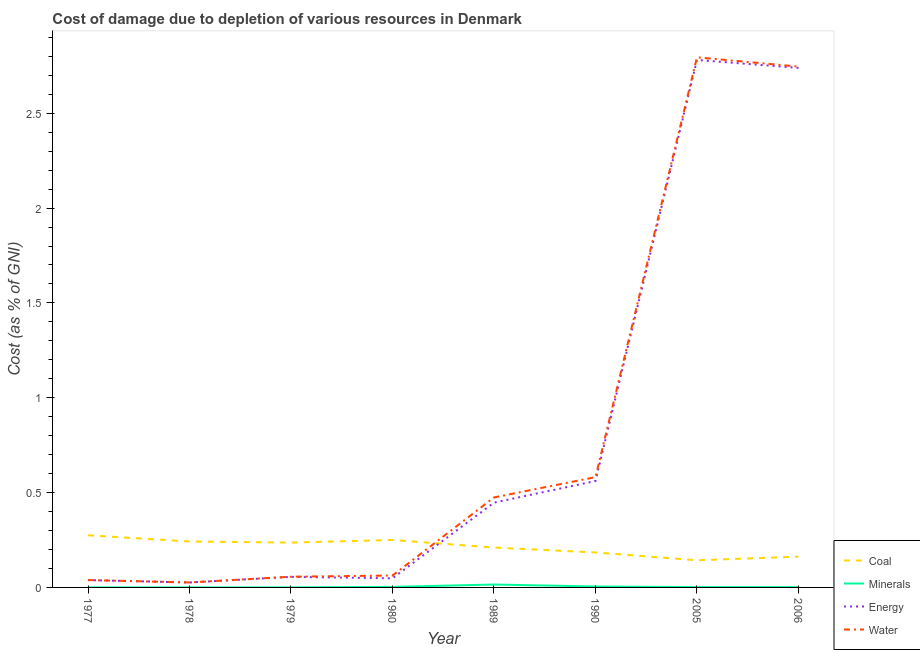How many different coloured lines are there?
Provide a short and direct response. 4. Does the line corresponding to cost of damage due to depletion of water intersect with the line corresponding to cost of damage due to depletion of coal?
Your response must be concise. Yes. What is the cost of damage due to depletion of energy in 2005?
Provide a short and direct response. 2.78. Across all years, what is the maximum cost of damage due to depletion of minerals?
Keep it short and to the point. 0.02. Across all years, what is the minimum cost of damage due to depletion of coal?
Your answer should be very brief. 0.14. In which year was the cost of damage due to depletion of water maximum?
Your response must be concise. 2005. In which year was the cost of damage due to depletion of coal minimum?
Offer a very short reply. 2005. What is the total cost of damage due to depletion of water in the graph?
Make the answer very short. 6.78. What is the difference between the cost of damage due to depletion of coal in 2005 and that in 2006?
Ensure brevity in your answer.  -0.02. What is the difference between the cost of damage due to depletion of coal in 1980 and the cost of damage due to depletion of energy in 1990?
Offer a very short reply. -0.31. What is the average cost of damage due to depletion of water per year?
Keep it short and to the point. 0.85. In the year 1989, what is the difference between the cost of damage due to depletion of energy and cost of damage due to depletion of water?
Your answer should be very brief. -0.03. What is the ratio of the cost of damage due to depletion of coal in 1979 to that in 1990?
Your answer should be very brief. 1.28. What is the difference between the highest and the second highest cost of damage due to depletion of minerals?
Provide a short and direct response. 0.01. What is the difference between the highest and the lowest cost of damage due to depletion of coal?
Give a very brief answer. 0.13. Is it the case that in every year, the sum of the cost of damage due to depletion of coal and cost of damage due to depletion of minerals is greater than the sum of cost of damage due to depletion of energy and cost of damage due to depletion of water?
Offer a terse response. No. Is it the case that in every year, the sum of the cost of damage due to depletion of coal and cost of damage due to depletion of minerals is greater than the cost of damage due to depletion of energy?
Give a very brief answer. No. Does the cost of damage due to depletion of water monotonically increase over the years?
Provide a short and direct response. No. Is the cost of damage due to depletion of energy strictly greater than the cost of damage due to depletion of water over the years?
Provide a succinct answer. No. Is the cost of damage due to depletion of energy strictly less than the cost of damage due to depletion of water over the years?
Give a very brief answer. Yes. How many lines are there?
Your answer should be very brief. 4. How many years are there in the graph?
Offer a terse response. 8. What is the difference between two consecutive major ticks on the Y-axis?
Your answer should be compact. 0.5. Does the graph contain grids?
Offer a terse response. No. Where does the legend appear in the graph?
Give a very brief answer. Bottom right. How are the legend labels stacked?
Provide a succinct answer. Vertical. What is the title of the graph?
Provide a succinct answer. Cost of damage due to depletion of various resources in Denmark . Does "Social equity" appear as one of the legend labels in the graph?
Keep it short and to the point. No. What is the label or title of the X-axis?
Your response must be concise. Year. What is the label or title of the Y-axis?
Provide a short and direct response. Cost (as % of GNI). What is the Cost (as % of GNI) of Coal in 1977?
Your answer should be compact. 0.27. What is the Cost (as % of GNI) of Minerals in 1977?
Provide a short and direct response. 0. What is the Cost (as % of GNI) of Energy in 1977?
Your answer should be very brief. 0.04. What is the Cost (as % of GNI) in Water in 1977?
Your answer should be compact. 0.04. What is the Cost (as % of GNI) in Coal in 1978?
Your answer should be very brief. 0.24. What is the Cost (as % of GNI) of Minerals in 1978?
Your response must be concise. 0. What is the Cost (as % of GNI) of Energy in 1978?
Your answer should be compact. 0.03. What is the Cost (as % of GNI) of Water in 1978?
Make the answer very short. 0.03. What is the Cost (as % of GNI) in Coal in 1979?
Ensure brevity in your answer.  0.24. What is the Cost (as % of GNI) in Minerals in 1979?
Your response must be concise. 0. What is the Cost (as % of GNI) in Energy in 1979?
Offer a very short reply. 0.06. What is the Cost (as % of GNI) in Water in 1979?
Keep it short and to the point. 0.06. What is the Cost (as % of GNI) in Coal in 1980?
Your answer should be compact. 0.25. What is the Cost (as % of GNI) in Minerals in 1980?
Give a very brief answer. 0. What is the Cost (as % of GNI) of Energy in 1980?
Give a very brief answer. 0.05. What is the Cost (as % of GNI) of Water in 1980?
Your answer should be very brief. 0.06. What is the Cost (as % of GNI) in Coal in 1989?
Provide a succinct answer. 0.21. What is the Cost (as % of GNI) in Minerals in 1989?
Ensure brevity in your answer.  0.02. What is the Cost (as % of GNI) in Energy in 1989?
Your answer should be compact. 0.45. What is the Cost (as % of GNI) in Water in 1989?
Your answer should be compact. 0.47. What is the Cost (as % of GNI) of Coal in 1990?
Your response must be concise. 0.18. What is the Cost (as % of GNI) of Minerals in 1990?
Offer a terse response. 0. What is the Cost (as % of GNI) of Energy in 1990?
Keep it short and to the point. 0.56. What is the Cost (as % of GNI) in Water in 1990?
Make the answer very short. 0.58. What is the Cost (as % of GNI) of Coal in 2005?
Keep it short and to the point. 0.14. What is the Cost (as % of GNI) in Minerals in 2005?
Make the answer very short. 0. What is the Cost (as % of GNI) of Energy in 2005?
Your answer should be very brief. 2.78. What is the Cost (as % of GNI) of Water in 2005?
Keep it short and to the point. 2.79. What is the Cost (as % of GNI) in Coal in 2006?
Your answer should be compact. 0.16. What is the Cost (as % of GNI) of Minerals in 2006?
Give a very brief answer. 0. What is the Cost (as % of GNI) in Energy in 2006?
Make the answer very short. 2.74. What is the Cost (as % of GNI) in Water in 2006?
Make the answer very short. 2.75. Across all years, what is the maximum Cost (as % of GNI) of Coal?
Offer a very short reply. 0.27. Across all years, what is the maximum Cost (as % of GNI) in Minerals?
Keep it short and to the point. 0.02. Across all years, what is the maximum Cost (as % of GNI) of Energy?
Offer a terse response. 2.78. Across all years, what is the maximum Cost (as % of GNI) in Water?
Your response must be concise. 2.79. Across all years, what is the minimum Cost (as % of GNI) of Coal?
Keep it short and to the point. 0.14. Across all years, what is the minimum Cost (as % of GNI) in Minerals?
Offer a very short reply. 0. Across all years, what is the minimum Cost (as % of GNI) of Energy?
Offer a very short reply. 0.03. Across all years, what is the minimum Cost (as % of GNI) of Water?
Give a very brief answer. 0.03. What is the total Cost (as % of GNI) of Coal in the graph?
Give a very brief answer. 1.7. What is the total Cost (as % of GNI) in Minerals in the graph?
Your answer should be compact. 0.03. What is the total Cost (as % of GNI) in Energy in the graph?
Keep it short and to the point. 6.7. What is the total Cost (as % of GNI) in Water in the graph?
Give a very brief answer. 6.78. What is the difference between the Cost (as % of GNI) in Coal in 1977 and that in 1978?
Offer a very short reply. 0.03. What is the difference between the Cost (as % of GNI) in Minerals in 1977 and that in 1978?
Your answer should be very brief. 0. What is the difference between the Cost (as % of GNI) of Energy in 1977 and that in 1978?
Give a very brief answer. 0.01. What is the difference between the Cost (as % of GNI) of Water in 1977 and that in 1978?
Keep it short and to the point. 0.01. What is the difference between the Cost (as % of GNI) of Coal in 1977 and that in 1979?
Offer a very short reply. 0.04. What is the difference between the Cost (as % of GNI) in Minerals in 1977 and that in 1979?
Keep it short and to the point. -0. What is the difference between the Cost (as % of GNI) in Energy in 1977 and that in 1979?
Your response must be concise. -0.02. What is the difference between the Cost (as % of GNI) in Water in 1977 and that in 1979?
Give a very brief answer. -0.02. What is the difference between the Cost (as % of GNI) of Coal in 1977 and that in 1980?
Your answer should be very brief. 0.02. What is the difference between the Cost (as % of GNI) of Minerals in 1977 and that in 1980?
Your answer should be very brief. -0. What is the difference between the Cost (as % of GNI) of Energy in 1977 and that in 1980?
Your response must be concise. -0.01. What is the difference between the Cost (as % of GNI) in Water in 1977 and that in 1980?
Provide a succinct answer. -0.02. What is the difference between the Cost (as % of GNI) of Coal in 1977 and that in 1989?
Offer a terse response. 0.06. What is the difference between the Cost (as % of GNI) in Minerals in 1977 and that in 1989?
Your answer should be compact. -0.02. What is the difference between the Cost (as % of GNI) in Energy in 1977 and that in 1989?
Offer a very short reply. -0.41. What is the difference between the Cost (as % of GNI) in Water in 1977 and that in 1989?
Your answer should be very brief. -0.44. What is the difference between the Cost (as % of GNI) in Coal in 1977 and that in 1990?
Offer a very short reply. 0.09. What is the difference between the Cost (as % of GNI) in Minerals in 1977 and that in 1990?
Offer a very short reply. -0. What is the difference between the Cost (as % of GNI) of Energy in 1977 and that in 1990?
Your response must be concise. -0.52. What is the difference between the Cost (as % of GNI) in Water in 1977 and that in 1990?
Keep it short and to the point. -0.54. What is the difference between the Cost (as % of GNI) in Coal in 1977 and that in 2005?
Your answer should be very brief. 0.13. What is the difference between the Cost (as % of GNI) of Minerals in 1977 and that in 2005?
Provide a short and direct response. -0. What is the difference between the Cost (as % of GNI) of Energy in 1977 and that in 2005?
Your answer should be very brief. -2.74. What is the difference between the Cost (as % of GNI) of Water in 1977 and that in 2005?
Provide a succinct answer. -2.76. What is the difference between the Cost (as % of GNI) in Coal in 1977 and that in 2006?
Provide a succinct answer. 0.11. What is the difference between the Cost (as % of GNI) in Minerals in 1977 and that in 2006?
Provide a succinct answer. -0. What is the difference between the Cost (as % of GNI) of Energy in 1977 and that in 2006?
Make the answer very short. -2.7. What is the difference between the Cost (as % of GNI) in Water in 1977 and that in 2006?
Provide a short and direct response. -2.71. What is the difference between the Cost (as % of GNI) in Coal in 1978 and that in 1979?
Provide a short and direct response. 0.01. What is the difference between the Cost (as % of GNI) of Minerals in 1978 and that in 1979?
Your answer should be very brief. -0. What is the difference between the Cost (as % of GNI) in Energy in 1978 and that in 1979?
Your response must be concise. -0.03. What is the difference between the Cost (as % of GNI) in Water in 1978 and that in 1979?
Provide a succinct answer. -0.03. What is the difference between the Cost (as % of GNI) in Coal in 1978 and that in 1980?
Offer a very short reply. -0.01. What is the difference between the Cost (as % of GNI) of Minerals in 1978 and that in 1980?
Offer a very short reply. -0. What is the difference between the Cost (as % of GNI) of Energy in 1978 and that in 1980?
Give a very brief answer. -0.02. What is the difference between the Cost (as % of GNI) of Water in 1978 and that in 1980?
Keep it short and to the point. -0.04. What is the difference between the Cost (as % of GNI) in Coal in 1978 and that in 1989?
Ensure brevity in your answer.  0.03. What is the difference between the Cost (as % of GNI) in Minerals in 1978 and that in 1989?
Provide a succinct answer. -0.02. What is the difference between the Cost (as % of GNI) of Energy in 1978 and that in 1989?
Offer a terse response. -0.42. What is the difference between the Cost (as % of GNI) in Water in 1978 and that in 1989?
Offer a very short reply. -0.45. What is the difference between the Cost (as % of GNI) in Coal in 1978 and that in 1990?
Ensure brevity in your answer.  0.06. What is the difference between the Cost (as % of GNI) of Minerals in 1978 and that in 1990?
Provide a short and direct response. -0. What is the difference between the Cost (as % of GNI) of Energy in 1978 and that in 1990?
Give a very brief answer. -0.54. What is the difference between the Cost (as % of GNI) of Water in 1978 and that in 1990?
Offer a terse response. -0.56. What is the difference between the Cost (as % of GNI) in Coal in 1978 and that in 2005?
Keep it short and to the point. 0.1. What is the difference between the Cost (as % of GNI) of Minerals in 1978 and that in 2005?
Your answer should be compact. -0. What is the difference between the Cost (as % of GNI) in Energy in 1978 and that in 2005?
Provide a short and direct response. -2.75. What is the difference between the Cost (as % of GNI) in Water in 1978 and that in 2005?
Keep it short and to the point. -2.77. What is the difference between the Cost (as % of GNI) in Coal in 1978 and that in 2006?
Offer a very short reply. 0.08. What is the difference between the Cost (as % of GNI) in Minerals in 1978 and that in 2006?
Provide a short and direct response. -0. What is the difference between the Cost (as % of GNI) in Energy in 1978 and that in 2006?
Your answer should be very brief. -2.71. What is the difference between the Cost (as % of GNI) in Water in 1978 and that in 2006?
Keep it short and to the point. -2.72. What is the difference between the Cost (as % of GNI) of Coal in 1979 and that in 1980?
Keep it short and to the point. -0.01. What is the difference between the Cost (as % of GNI) in Minerals in 1979 and that in 1980?
Your response must be concise. -0. What is the difference between the Cost (as % of GNI) of Energy in 1979 and that in 1980?
Provide a short and direct response. 0.01. What is the difference between the Cost (as % of GNI) in Water in 1979 and that in 1980?
Offer a very short reply. -0.01. What is the difference between the Cost (as % of GNI) in Coal in 1979 and that in 1989?
Your answer should be very brief. 0.03. What is the difference between the Cost (as % of GNI) of Minerals in 1979 and that in 1989?
Offer a very short reply. -0.02. What is the difference between the Cost (as % of GNI) in Energy in 1979 and that in 1989?
Offer a terse response. -0.39. What is the difference between the Cost (as % of GNI) in Water in 1979 and that in 1989?
Provide a succinct answer. -0.42. What is the difference between the Cost (as % of GNI) of Coal in 1979 and that in 1990?
Offer a very short reply. 0.05. What is the difference between the Cost (as % of GNI) in Minerals in 1979 and that in 1990?
Offer a terse response. -0. What is the difference between the Cost (as % of GNI) in Energy in 1979 and that in 1990?
Give a very brief answer. -0.51. What is the difference between the Cost (as % of GNI) of Water in 1979 and that in 1990?
Make the answer very short. -0.53. What is the difference between the Cost (as % of GNI) in Coal in 1979 and that in 2005?
Your answer should be compact. 0.09. What is the difference between the Cost (as % of GNI) in Minerals in 1979 and that in 2005?
Make the answer very short. -0. What is the difference between the Cost (as % of GNI) of Energy in 1979 and that in 2005?
Your response must be concise. -2.73. What is the difference between the Cost (as % of GNI) of Water in 1979 and that in 2005?
Provide a short and direct response. -2.74. What is the difference between the Cost (as % of GNI) of Coal in 1979 and that in 2006?
Ensure brevity in your answer.  0.07. What is the difference between the Cost (as % of GNI) in Minerals in 1979 and that in 2006?
Your answer should be compact. -0. What is the difference between the Cost (as % of GNI) of Energy in 1979 and that in 2006?
Offer a very short reply. -2.68. What is the difference between the Cost (as % of GNI) in Water in 1979 and that in 2006?
Offer a terse response. -2.69. What is the difference between the Cost (as % of GNI) of Coal in 1980 and that in 1989?
Make the answer very short. 0.04. What is the difference between the Cost (as % of GNI) of Minerals in 1980 and that in 1989?
Keep it short and to the point. -0.01. What is the difference between the Cost (as % of GNI) in Energy in 1980 and that in 1989?
Ensure brevity in your answer.  -0.4. What is the difference between the Cost (as % of GNI) in Water in 1980 and that in 1989?
Ensure brevity in your answer.  -0.41. What is the difference between the Cost (as % of GNI) of Coal in 1980 and that in 1990?
Offer a very short reply. 0.07. What is the difference between the Cost (as % of GNI) in Minerals in 1980 and that in 1990?
Keep it short and to the point. -0. What is the difference between the Cost (as % of GNI) of Energy in 1980 and that in 1990?
Provide a short and direct response. -0.51. What is the difference between the Cost (as % of GNI) in Water in 1980 and that in 1990?
Keep it short and to the point. -0.52. What is the difference between the Cost (as % of GNI) of Coal in 1980 and that in 2005?
Provide a succinct answer. 0.11. What is the difference between the Cost (as % of GNI) in Minerals in 1980 and that in 2005?
Make the answer very short. 0. What is the difference between the Cost (as % of GNI) of Energy in 1980 and that in 2005?
Your answer should be compact. -2.73. What is the difference between the Cost (as % of GNI) of Water in 1980 and that in 2005?
Make the answer very short. -2.73. What is the difference between the Cost (as % of GNI) of Coal in 1980 and that in 2006?
Your answer should be very brief. 0.09. What is the difference between the Cost (as % of GNI) in Minerals in 1980 and that in 2006?
Your answer should be compact. 0. What is the difference between the Cost (as % of GNI) of Energy in 1980 and that in 2006?
Your answer should be very brief. -2.69. What is the difference between the Cost (as % of GNI) in Water in 1980 and that in 2006?
Provide a short and direct response. -2.68. What is the difference between the Cost (as % of GNI) of Coal in 1989 and that in 1990?
Your answer should be very brief. 0.03. What is the difference between the Cost (as % of GNI) in Minerals in 1989 and that in 1990?
Your answer should be compact. 0.01. What is the difference between the Cost (as % of GNI) in Energy in 1989 and that in 1990?
Offer a very short reply. -0.11. What is the difference between the Cost (as % of GNI) in Water in 1989 and that in 1990?
Ensure brevity in your answer.  -0.11. What is the difference between the Cost (as % of GNI) in Coal in 1989 and that in 2005?
Keep it short and to the point. 0.07. What is the difference between the Cost (as % of GNI) of Minerals in 1989 and that in 2005?
Provide a succinct answer. 0.01. What is the difference between the Cost (as % of GNI) of Energy in 1989 and that in 2005?
Your answer should be compact. -2.33. What is the difference between the Cost (as % of GNI) of Water in 1989 and that in 2005?
Give a very brief answer. -2.32. What is the difference between the Cost (as % of GNI) of Coal in 1989 and that in 2006?
Provide a succinct answer. 0.05. What is the difference between the Cost (as % of GNI) in Minerals in 1989 and that in 2006?
Provide a short and direct response. 0.01. What is the difference between the Cost (as % of GNI) in Energy in 1989 and that in 2006?
Your response must be concise. -2.29. What is the difference between the Cost (as % of GNI) of Water in 1989 and that in 2006?
Your response must be concise. -2.27. What is the difference between the Cost (as % of GNI) in Coal in 1990 and that in 2005?
Your answer should be compact. 0.04. What is the difference between the Cost (as % of GNI) of Minerals in 1990 and that in 2005?
Keep it short and to the point. 0. What is the difference between the Cost (as % of GNI) in Energy in 1990 and that in 2005?
Your answer should be compact. -2.22. What is the difference between the Cost (as % of GNI) of Water in 1990 and that in 2005?
Provide a succinct answer. -2.21. What is the difference between the Cost (as % of GNI) in Coal in 1990 and that in 2006?
Make the answer very short. 0.02. What is the difference between the Cost (as % of GNI) in Minerals in 1990 and that in 2006?
Give a very brief answer. 0. What is the difference between the Cost (as % of GNI) of Energy in 1990 and that in 2006?
Provide a short and direct response. -2.18. What is the difference between the Cost (as % of GNI) of Water in 1990 and that in 2006?
Ensure brevity in your answer.  -2.16. What is the difference between the Cost (as % of GNI) of Coal in 2005 and that in 2006?
Provide a short and direct response. -0.02. What is the difference between the Cost (as % of GNI) in Energy in 2005 and that in 2006?
Provide a succinct answer. 0.04. What is the difference between the Cost (as % of GNI) in Water in 2005 and that in 2006?
Your response must be concise. 0.05. What is the difference between the Cost (as % of GNI) of Coal in 1977 and the Cost (as % of GNI) of Minerals in 1978?
Your answer should be compact. 0.27. What is the difference between the Cost (as % of GNI) in Coal in 1977 and the Cost (as % of GNI) in Energy in 1978?
Give a very brief answer. 0.25. What is the difference between the Cost (as % of GNI) of Coal in 1977 and the Cost (as % of GNI) of Water in 1978?
Give a very brief answer. 0.25. What is the difference between the Cost (as % of GNI) in Minerals in 1977 and the Cost (as % of GNI) in Energy in 1978?
Your answer should be very brief. -0.03. What is the difference between the Cost (as % of GNI) in Minerals in 1977 and the Cost (as % of GNI) in Water in 1978?
Provide a succinct answer. -0.03. What is the difference between the Cost (as % of GNI) of Energy in 1977 and the Cost (as % of GNI) of Water in 1978?
Your answer should be compact. 0.01. What is the difference between the Cost (as % of GNI) in Coal in 1977 and the Cost (as % of GNI) in Minerals in 1979?
Your answer should be very brief. 0.27. What is the difference between the Cost (as % of GNI) of Coal in 1977 and the Cost (as % of GNI) of Energy in 1979?
Provide a short and direct response. 0.22. What is the difference between the Cost (as % of GNI) of Coal in 1977 and the Cost (as % of GNI) of Water in 1979?
Make the answer very short. 0.22. What is the difference between the Cost (as % of GNI) in Minerals in 1977 and the Cost (as % of GNI) in Energy in 1979?
Make the answer very short. -0.06. What is the difference between the Cost (as % of GNI) in Minerals in 1977 and the Cost (as % of GNI) in Water in 1979?
Provide a succinct answer. -0.06. What is the difference between the Cost (as % of GNI) of Energy in 1977 and the Cost (as % of GNI) of Water in 1979?
Offer a very short reply. -0.02. What is the difference between the Cost (as % of GNI) in Coal in 1977 and the Cost (as % of GNI) in Minerals in 1980?
Provide a short and direct response. 0.27. What is the difference between the Cost (as % of GNI) of Coal in 1977 and the Cost (as % of GNI) of Energy in 1980?
Ensure brevity in your answer.  0.23. What is the difference between the Cost (as % of GNI) of Coal in 1977 and the Cost (as % of GNI) of Water in 1980?
Give a very brief answer. 0.21. What is the difference between the Cost (as % of GNI) of Minerals in 1977 and the Cost (as % of GNI) of Energy in 1980?
Ensure brevity in your answer.  -0.05. What is the difference between the Cost (as % of GNI) in Minerals in 1977 and the Cost (as % of GNI) in Water in 1980?
Make the answer very short. -0.06. What is the difference between the Cost (as % of GNI) in Energy in 1977 and the Cost (as % of GNI) in Water in 1980?
Provide a short and direct response. -0.02. What is the difference between the Cost (as % of GNI) in Coal in 1977 and the Cost (as % of GNI) in Minerals in 1989?
Make the answer very short. 0.26. What is the difference between the Cost (as % of GNI) in Coal in 1977 and the Cost (as % of GNI) in Energy in 1989?
Keep it short and to the point. -0.17. What is the difference between the Cost (as % of GNI) of Coal in 1977 and the Cost (as % of GNI) of Water in 1989?
Provide a succinct answer. -0.2. What is the difference between the Cost (as % of GNI) in Minerals in 1977 and the Cost (as % of GNI) in Energy in 1989?
Offer a very short reply. -0.45. What is the difference between the Cost (as % of GNI) of Minerals in 1977 and the Cost (as % of GNI) of Water in 1989?
Keep it short and to the point. -0.47. What is the difference between the Cost (as % of GNI) in Energy in 1977 and the Cost (as % of GNI) in Water in 1989?
Ensure brevity in your answer.  -0.44. What is the difference between the Cost (as % of GNI) of Coal in 1977 and the Cost (as % of GNI) of Minerals in 1990?
Keep it short and to the point. 0.27. What is the difference between the Cost (as % of GNI) in Coal in 1977 and the Cost (as % of GNI) in Energy in 1990?
Provide a succinct answer. -0.29. What is the difference between the Cost (as % of GNI) in Coal in 1977 and the Cost (as % of GNI) in Water in 1990?
Make the answer very short. -0.31. What is the difference between the Cost (as % of GNI) in Minerals in 1977 and the Cost (as % of GNI) in Energy in 1990?
Give a very brief answer. -0.56. What is the difference between the Cost (as % of GNI) in Minerals in 1977 and the Cost (as % of GNI) in Water in 1990?
Make the answer very short. -0.58. What is the difference between the Cost (as % of GNI) in Energy in 1977 and the Cost (as % of GNI) in Water in 1990?
Provide a short and direct response. -0.54. What is the difference between the Cost (as % of GNI) of Coal in 1977 and the Cost (as % of GNI) of Minerals in 2005?
Offer a terse response. 0.27. What is the difference between the Cost (as % of GNI) of Coal in 1977 and the Cost (as % of GNI) of Energy in 2005?
Keep it short and to the point. -2.51. What is the difference between the Cost (as % of GNI) of Coal in 1977 and the Cost (as % of GNI) of Water in 2005?
Give a very brief answer. -2.52. What is the difference between the Cost (as % of GNI) in Minerals in 1977 and the Cost (as % of GNI) in Energy in 2005?
Offer a very short reply. -2.78. What is the difference between the Cost (as % of GNI) in Minerals in 1977 and the Cost (as % of GNI) in Water in 2005?
Your answer should be very brief. -2.79. What is the difference between the Cost (as % of GNI) of Energy in 1977 and the Cost (as % of GNI) of Water in 2005?
Make the answer very short. -2.76. What is the difference between the Cost (as % of GNI) of Coal in 1977 and the Cost (as % of GNI) of Minerals in 2006?
Offer a very short reply. 0.27. What is the difference between the Cost (as % of GNI) of Coal in 1977 and the Cost (as % of GNI) of Energy in 2006?
Your answer should be very brief. -2.46. What is the difference between the Cost (as % of GNI) in Coal in 1977 and the Cost (as % of GNI) in Water in 2006?
Ensure brevity in your answer.  -2.47. What is the difference between the Cost (as % of GNI) of Minerals in 1977 and the Cost (as % of GNI) of Energy in 2006?
Provide a short and direct response. -2.74. What is the difference between the Cost (as % of GNI) of Minerals in 1977 and the Cost (as % of GNI) of Water in 2006?
Offer a very short reply. -2.75. What is the difference between the Cost (as % of GNI) of Energy in 1977 and the Cost (as % of GNI) of Water in 2006?
Ensure brevity in your answer.  -2.71. What is the difference between the Cost (as % of GNI) of Coal in 1978 and the Cost (as % of GNI) of Minerals in 1979?
Keep it short and to the point. 0.24. What is the difference between the Cost (as % of GNI) of Coal in 1978 and the Cost (as % of GNI) of Energy in 1979?
Keep it short and to the point. 0.19. What is the difference between the Cost (as % of GNI) in Coal in 1978 and the Cost (as % of GNI) in Water in 1979?
Make the answer very short. 0.19. What is the difference between the Cost (as % of GNI) in Minerals in 1978 and the Cost (as % of GNI) in Energy in 1979?
Keep it short and to the point. -0.06. What is the difference between the Cost (as % of GNI) in Minerals in 1978 and the Cost (as % of GNI) in Water in 1979?
Your answer should be compact. -0.06. What is the difference between the Cost (as % of GNI) in Energy in 1978 and the Cost (as % of GNI) in Water in 1979?
Your answer should be very brief. -0.03. What is the difference between the Cost (as % of GNI) in Coal in 1978 and the Cost (as % of GNI) in Minerals in 1980?
Provide a succinct answer. 0.24. What is the difference between the Cost (as % of GNI) in Coal in 1978 and the Cost (as % of GNI) in Energy in 1980?
Offer a very short reply. 0.19. What is the difference between the Cost (as % of GNI) of Coal in 1978 and the Cost (as % of GNI) of Water in 1980?
Your answer should be very brief. 0.18. What is the difference between the Cost (as % of GNI) of Minerals in 1978 and the Cost (as % of GNI) of Energy in 1980?
Give a very brief answer. -0.05. What is the difference between the Cost (as % of GNI) in Minerals in 1978 and the Cost (as % of GNI) in Water in 1980?
Your response must be concise. -0.06. What is the difference between the Cost (as % of GNI) in Energy in 1978 and the Cost (as % of GNI) in Water in 1980?
Your answer should be compact. -0.04. What is the difference between the Cost (as % of GNI) of Coal in 1978 and the Cost (as % of GNI) of Minerals in 1989?
Offer a terse response. 0.23. What is the difference between the Cost (as % of GNI) in Coal in 1978 and the Cost (as % of GNI) in Energy in 1989?
Your answer should be compact. -0.2. What is the difference between the Cost (as % of GNI) in Coal in 1978 and the Cost (as % of GNI) in Water in 1989?
Provide a short and direct response. -0.23. What is the difference between the Cost (as % of GNI) in Minerals in 1978 and the Cost (as % of GNI) in Energy in 1989?
Ensure brevity in your answer.  -0.45. What is the difference between the Cost (as % of GNI) of Minerals in 1978 and the Cost (as % of GNI) of Water in 1989?
Offer a terse response. -0.47. What is the difference between the Cost (as % of GNI) in Energy in 1978 and the Cost (as % of GNI) in Water in 1989?
Your answer should be compact. -0.45. What is the difference between the Cost (as % of GNI) of Coal in 1978 and the Cost (as % of GNI) of Minerals in 1990?
Your answer should be very brief. 0.24. What is the difference between the Cost (as % of GNI) of Coal in 1978 and the Cost (as % of GNI) of Energy in 1990?
Offer a terse response. -0.32. What is the difference between the Cost (as % of GNI) of Coal in 1978 and the Cost (as % of GNI) of Water in 1990?
Make the answer very short. -0.34. What is the difference between the Cost (as % of GNI) of Minerals in 1978 and the Cost (as % of GNI) of Energy in 1990?
Make the answer very short. -0.56. What is the difference between the Cost (as % of GNI) of Minerals in 1978 and the Cost (as % of GNI) of Water in 1990?
Ensure brevity in your answer.  -0.58. What is the difference between the Cost (as % of GNI) in Energy in 1978 and the Cost (as % of GNI) in Water in 1990?
Provide a succinct answer. -0.56. What is the difference between the Cost (as % of GNI) of Coal in 1978 and the Cost (as % of GNI) of Minerals in 2005?
Your answer should be very brief. 0.24. What is the difference between the Cost (as % of GNI) of Coal in 1978 and the Cost (as % of GNI) of Energy in 2005?
Ensure brevity in your answer.  -2.54. What is the difference between the Cost (as % of GNI) of Coal in 1978 and the Cost (as % of GNI) of Water in 2005?
Make the answer very short. -2.55. What is the difference between the Cost (as % of GNI) of Minerals in 1978 and the Cost (as % of GNI) of Energy in 2005?
Offer a very short reply. -2.78. What is the difference between the Cost (as % of GNI) in Minerals in 1978 and the Cost (as % of GNI) in Water in 2005?
Offer a very short reply. -2.79. What is the difference between the Cost (as % of GNI) in Energy in 1978 and the Cost (as % of GNI) in Water in 2005?
Your answer should be very brief. -2.77. What is the difference between the Cost (as % of GNI) in Coal in 1978 and the Cost (as % of GNI) in Minerals in 2006?
Provide a succinct answer. 0.24. What is the difference between the Cost (as % of GNI) of Coal in 1978 and the Cost (as % of GNI) of Energy in 2006?
Offer a very short reply. -2.5. What is the difference between the Cost (as % of GNI) in Coal in 1978 and the Cost (as % of GNI) in Water in 2006?
Make the answer very short. -2.5. What is the difference between the Cost (as % of GNI) in Minerals in 1978 and the Cost (as % of GNI) in Energy in 2006?
Offer a terse response. -2.74. What is the difference between the Cost (as % of GNI) in Minerals in 1978 and the Cost (as % of GNI) in Water in 2006?
Provide a succinct answer. -2.75. What is the difference between the Cost (as % of GNI) of Energy in 1978 and the Cost (as % of GNI) of Water in 2006?
Your answer should be compact. -2.72. What is the difference between the Cost (as % of GNI) in Coal in 1979 and the Cost (as % of GNI) in Minerals in 1980?
Give a very brief answer. 0.23. What is the difference between the Cost (as % of GNI) in Coal in 1979 and the Cost (as % of GNI) in Energy in 1980?
Keep it short and to the point. 0.19. What is the difference between the Cost (as % of GNI) in Coal in 1979 and the Cost (as % of GNI) in Water in 1980?
Provide a succinct answer. 0.17. What is the difference between the Cost (as % of GNI) of Minerals in 1979 and the Cost (as % of GNI) of Energy in 1980?
Provide a succinct answer. -0.05. What is the difference between the Cost (as % of GNI) of Minerals in 1979 and the Cost (as % of GNI) of Water in 1980?
Ensure brevity in your answer.  -0.06. What is the difference between the Cost (as % of GNI) of Energy in 1979 and the Cost (as % of GNI) of Water in 1980?
Ensure brevity in your answer.  -0.01. What is the difference between the Cost (as % of GNI) of Coal in 1979 and the Cost (as % of GNI) of Minerals in 1989?
Your answer should be very brief. 0.22. What is the difference between the Cost (as % of GNI) in Coal in 1979 and the Cost (as % of GNI) in Energy in 1989?
Your answer should be compact. -0.21. What is the difference between the Cost (as % of GNI) of Coal in 1979 and the Cost (as % of GNI) of Water in 1989?
Your answer should be very brief. -0.24. What is the difference between the Cost (as % of GNI) in Minerals in 1979 and the Cost (as % of GNI) in Energy in 1989?
Keep it short and to the point. -0.45. What is the difference between the Cost (as % of GNI) in Minerals in 1979 and the Cost (as % of GNI) in Water in 1989?
Your answer should be compact. -0.47. What is the difference between the Cost (as % of GNI) of Energy in 1979 and the Cost (as % of GNI) of Water in 1989?
Offer a very short reply. -0.42. What is the difference between the Cost (as % of GNI) of Coal in 1979 and the Cost (as % of GNI) of Minerals in 1990?
Your response must be concise. 0.23. What is the difference between the Cost (as % of GNI) in Coal in 1979 and the Cost (as % of GNI) in Energy in 1990?
Your response must be concise. -0.32. What is the difference between the Cost (as % of GNI) in Coal in 1979 and the Cost (as % of GNI) in Water in 1990?
Your answer should be compact. -0.35. What is the difference between the Cost (as % of GNI) of Minerals in 1979 and the Cost (as % of GNI) of Energy in 1990?
Provide a short and direct response. -0.56. What is the difference between the Cost (as % of GNI) of Minerals in 1979 and the Cost (as % of GNI) of Water in 1990?
Your answer should be compact. -0.58. What is the difference between the Cost (as % of GNI) in Energy in 1979 and the Cost (as % of GNI) in Water in 1990?
Keep it short and to the point. -0.53. What is the difference between the Cost (as % of GNI) in Coal in 1979 and the Cost (as % of GNI) in Minerals in 2005?
Make the answer very short. 0.23. What is the difference between the Cost (as % of GNI) of Coal in 1979 and the Cost (as % of GNI) of Energy in 2005?
Your response must be concise. -2.54. What is the difference between the Cost (as % of GNI) in Coal in 1979 and the Cost (as % of GNI) in Water in 2005?
Your answer should be very brief. -2.56. What is the difference between the Cost (as % of GNI) in Minerals in 1979 and the Cost (as % of GNI) in Energy in 2005?
Your response must be concise. -2.78. What is the difference between the Cost (as % of GNI) in Minerals in 1979 and the Cost (as % of GNI) in Water in 2005?
Offer a terse response. -2.79. What is the difference between the Cost (as % of GNI) in Energy in 1979 and the Cost (as % of GNI) in Water in 2005?
Your answer should be very brief. -2.74. What is the difference between the Cost (as % of GNI) of Coal in 1979 and the Cost (as % of GNI) of Minerals in 2006?
Give a very brief answer. 0.23. What is the difference between the Cost (as % of GNI) of Coal in 1979 and the Cost (as % of GNI) of Energy in 2006?
Your answer should be compact. -2.5. What is the difference between the Cost (as % of GNI) of Coal in 1979 and the Cost (as % of GNI) of Water in 2006?
Offer a terse response. -2.51. What is the difference between the Cost (as % of GNI) in Minerals in 1979 and the Cost (as % of GNI) in Energy in 2006?
Provide a succinct answer. -2.74. What is the difference between the Cost (as % of GNI) of Minerals in 1979 and the Cost (as % of GNI) of Water in 2006?
Your answer should be very brief. -2.75. What is the difference between the Cost (as % of GNI) in Energy in 1979 and the Cost (as % of GNI) in Water in 2006?
Your answer should be very brief. -2.69. What is the difference between the Cost (as % of GNI) of Coal in 1980 and the Cost (as % of GNI) of Minerals in 1989?
Make the answer very short. 0.23. What is the difference between the Cost (as % of GNI) in Coal in 1980 and the Cost (as % of GNI) in Energy in 1989?
Your answer should be very brief. -0.2. What is the difference between the Cost (as % of GNI) in Coal in 1980 and the Cost (as % of GNI) in Water in 1989?
Your answer should be very brief. -0.22. What is the difference between the Cost (as % of GNI) in Minerals in 1980 and the Cost (as % of GNI) in Energy in 1989?
Keep it short and to the point. -0.44. What is the difference between the Cost (as % of GNI) in Minerals in 1980 and the Cost (as % of GNI) in Water in 1989?
Your answer should be compact. -0.47. What is the difference between the Cost (as % of GNI) in Energy in 1980 and the Cost (as % of GNI) in Water in 1989?
Provide a succinct answer. -0.43. What is the difference between the Cost (as % of GNI) of Coal in 1980 and the Cost (as % of GNI) of Minerals in 1990?
Keep it short and to the point. 0.25. What is the difference between the Cost (as % of GNI) of Coal in 1980 and the Cost (as % of GNI) of Energy in 1990?
Give a very brief answer. -0.31. What is the difference between the Cost (as % of GNI) of Coal in 1980 and the Cost (as % of GNI) of Water in 1990?
Provide a succinct answer. -0.33. What is the difference between the Cost (as % of GNI) of Minerals in 1980 and the Cost (as % of GNI) of Energy in 1990?
Make the answer very short. -0.56. What is the difference between the Cost (as % of GNI) of Minerals in 1980 and the Cost (as % of GNI) of Water in 1990?
Offer a terse response. -0.58. What is the difference between the Cost (as % of GNI) of Energy in 1980 and the Cost (as % of GNI) of Water in 1990?
Ensure brevity in your answer.  -0.53. What is the difference between the Cost (as % of GNI) of Coal in 1980 and the Cost (as % of GNI) of Minerals in 2005?
Provide a short and direct response. 0.25. What is the difference between the Cost (as % of GNI) in Coal in 1980 and the Cost (as % of GNI) in Energy in 2005?
Provide a short and direct response. -2.53. What is the difference between the Cost (as % of GNI) of Coal in 1980 and the Cost (as % of GNI) of Water in 2005?
Provide a short and direct response. -2.54. What is the difference between the Cost (as % of GNI) of Minerals in 1980 and the Cost (as % of GNI) of Energy in 2005?
Offer a terse response. -2.78. What is the difference between the Cost (as % of GNI) in Minerals in 1980 and the Cost (as % of GNI) in Water in 2005?
Your response must be concise. -2.79. What is the difference between the Cost (as % of GNI) of Energy in 1980 and the Cost (as % of GNI) of Water in 2005?
Offer a terse response. -2.75. What is the difference between the Cost (as % of GNI) of Coal in 1980 and the Cost (as % of GNI) of Minerals in 2006?
Provide a succinct answer. 0.25. What is the difference between the Cost (as % of GNI) of Coal in 1980 and the Cost (as % of GNI) of Energy in 2006?
Provide a succinct answer. -2.49. What is the difference between the Cost (as % of GNI) in Coal in 1980 and the Cost (as % of GNI) in Water in 2006?
Ensure brevity in your answer.  -2.5. What is the difference between the Cost (as % of GNI) of Minerals in 1980 and the Cost (as % of GNI) of Energy in 2006?
Give a very brief answer. -2.74. What is the difference between the Cost (as % of GNI) in Minerals in 1980 and the Cost (as % of GNI) in Water in 2006?
Give a very brief answer. -2.74. What is the difference between the Cost (as % of GNI) of Energy in 1980 and the Cost (as % of GNI) of Water in 2006?
Make the answer very short. -2.7. What is the difference between the Cost (as % of GNI) in Coal in 1989 and the Cost (as % of GNI) in Minerals in 1990?
Provide a succinct answer. 0.21. What is the difference between the Cost (as % of GNI) of Coal in 1989 and the Cost (as % of GNI) of Energy in 1990?
Your answer should be compact. -0.35. What is the difference between the Cost (as % of GNI) of Coal in 1989 and the Cost (as % of GNI) of Water in 1990?
Give a very brief answer. -0.37. What is the difference between the Cost (as % of GNI) of Minerals in 1989 and the Cost (as % of GNI) of Energy in 1990?
Make the answer very short. -0.55. What is the difference between the Cost (as % of GNI) of Minerals in 1989 and the Cost (as % of GNI) of Water in 1990?
Offer a very short reply. -0.57. What is the difference between the Cost (as % of GNI) of Energy in 1989 and the Cost (as % of GNI) of Water in 1990?
Offer a terse response. -0.13. What is the difference between the Cost (as % of GNI) of Coal in 1989 and the Cost (as % of GNI) of Minerals in 2005?
Ensure brevity in your answer.  0.21. What is the difference between the Cost (as % of GNI) of Coal in 1989 and the Cost (as % of GNI) of Energy in 2005?
Offer a terse response. -2.57. What is the difference between the Cost (as % of GNI) of Coal in 1989 and the Cost (as % of GNI) of Water in 2005?
Your answer should be compact. -2.58. What is the difference between the Cost (as % of GNI) of Minerals in 1989 and the Cost (as % of GNI) of Energy in 2005?
Your answer should be very brief. -2.77. What is the difference between the Cost (as % of GNI) in Minerals in 1989 and the Cost (as % of GNI) in Water in 2005?
Ensure brevity in your answer.  -2.78. What is the difference between the Cost (as % of GNI) in Energy in 1989 and the Cost (as % of GNI) in Water in 2005?
Provide a succinct answer. -2.35. What is the difference between the Cost (as % of GNI) in Coal in 1989 and the Cost (as % of GNI) in Minerals in 2006?
Offer a terse response. 0.21. What is the difference between the Cost (as % of GNI) in Coal in 1989 and the Cost (as % of GNI) in Energy in 2006?
Provide a short and direct response. -2.53. What is the difference between the Cost (as % of GNI) of Coal in 1989 and the Cost (as % of GNI) of Water in 2006?
Offer a very short reply. -2.54. What is the difference between the Cost (as % of GNI) in Minerals in 1989 and the Cost (as % of GNI) in Energy in 2006?
Ensure brevity in your answer.  -2.72. What is the difference between the Cost (as % of GNI) of Minerals in 1989 and the Cost (as % of GNI) of Water in 2006?
Provide a succinct answer. -2.73. What is the difference between the Cost (as % of GNI) of Energy in 1989 and the Cost (as % of GNI) of Water in 2006?
Your answer should be compact. -2.3. What is the difference between the Cost (as % of GNI) of Coal in 1990 and the Cost (as % of GNI) of Minerals in 2005?
Provide a short and direct response. 0.18. What is the difference between the Cost (as % of GNI) in Coal in 1990 and the Cost (as % of GNI) in Energy in 2005?
Your response must be concise. -2.6. What is the difference between the Cost (as % of GNI) in Coal in 1990 and the Cost (as % of GNI) in Water in 2005?
Keep it short and to the point. -2.61. What is the difference between the Cost (as % of GNI) of Minerals in 1990 and the Cost (as % of GNI) of Energy in 2005?
Offer a very short reply. -2.78. What is the difference between the Cost (as % of GNI) in Minerals in 1990 and the Cost (as % of GNI) in Water in 2005?
Give a very brief answer. -2.79. What is the difference between the Cost (as % of GNI) of Energy in 1990 and the Cost (as % of GNI) of Water in 2005?
Offer a very short reply. -2.23. What is the difference between the Cost (as % of GNI) of Coal in 1990 and the Cost (as % of GNI) of Minerals in 2006?
Provide a short and direct response. 0.18. What is the difference between the Cost (as % of GNI) of Coal in 1990 and the Cost (as % of GNI) of Energy in 2006?
Your answer should be very brief. -2.55. What is the difference between the Cost (as % of GNI) of Coal in 1990 and the Cost (as % of GNI) of Water in 2006?
Your answer should be compact. -2.56. What is the difference between the Cost (as % of GNI) in Minerals in 1990 and the Cost (as % of GNI) in Energy in 2006?
Keep it short and to the point. -2.73. What is the difference between the Cost (as % of GNI) of Minerals in 1990 and the Cost (as % of GNI) of Water in 2006?
Your response must be concise. -2.74. What is the difference between the Cost (as % of GNI) of Energy in 1990 and the Cost (as % of GNI) of Water in 2006?
Offer a terse response. -2.19. What is the difference between the Cost (as % of GNI) of Coal in 2005 and the Cost (as % of GNI) of Minerals in 2006?
Make the answer very short. 0.14. What is the difference between the Cost (as % of GNI) in Coal in 2005 and the Cost (as % of GNI) in Energy in 2006?
Provide a succinct answer. -2.6. What is the difference between the Cost (as % of GNI) in Coal in 2005 and the Cost (as % of GNI) in Water in 2006?
Offer a terse response. -2.6. What is the difference between the Cost (as % of GNI) of Minerals in 2005 and the Cost (as % of GNI) of Energy in 2006?
Provide a succinct answer. -2.74. What is the difference between the Cost (as % of GNI) in Minerals in 2005 and the Cost (as % of GNI) in Water in 2006?
Ensure brevity in your answer.  -2.74. What is the difference between the Cost (as % of GNI) of Energy in 2005 and the Cost (as % of GNI) of Water in 2006?
Your answer should be compact. 0.03. What is the average Cost (as % of GNI) in Coal per year?
Provide a succinct answer. 0.21. What is the average Cost (as % of GNI) of Minerals per year?
Your answer should be very brief. 0. What is the average Cost (as % of GNI) of Energy per year?
Keep it short and to the point. 0.84. What is the average Cost (as % of GNI) in Water per year?
Give a very brief answer. 0.85. In the year 1977, what is the difference between the Cost (as % of GNI) of Coal and Cost (as % of GNI) of Minerals?
Your response must be concise. 0.27. In the year 1977, what is the difference between the Cost (as % of GNI) in Coal and Cost (as % of GNI) in Energy?
Provide a succinct answer. 0.24. In the year 1977, what is the difference between the Cost (as % of GNI) in Coal and Cost (as % of GNI) in Water?
Your response must be concise. 0.24. In the year 1977, what is the difference between the Cost (as % of GNI) of Minerals and Cost (as % of GNI) of Energy?
Make the answer very short. -0.04. In the year 1977, what is the difference between the Cost (as % of GNI) of Minerals and Cost (as % of GNI) of Water?
Provide a succinct answer. -0.04. In the year 1977, what is the difference between the Cost (as % of GNI) in Energy and Cost (as % of GNI) in Water?
Your response must be concise. -0. In the year 1978, what is the difference between the Cost (as % of GNI) in Coal and Cost (as % of GNI) in Minerals?
Your answer should be compact. 0.24. In the year 1978, what is the difference between the Cost (as % of GNI) in Coal and Cost (as % of GNI) in Energy?
Your answer should be compact. 0.22. In the year 1978, what is the difference between the Cost (as % of GNI) in Coal and Cost (as % of GNI) in Water?
Offer a very short reply. 0.22. In the year 1978, what is the difference between the Cost (as % of GNI) of Minerals and Cost (as % of GNI) of Energy?
Make the answer very short. -0.03. In the year 1978, what is the difference between the Cost (as % of GNI) of Minerals and Cost (as % of GNI) of Water?
Ensure brevity in your answer.  -0.03. In the year 1978, what is the difference between the Cost (as % of GNI) of Energy and Cost (as % of GNI) of Water?
Keep it short and to the point. -0. In the year 1979, what is the difference between the Cost (as % of GNI) of Coal and Cost (as % of GNI) of Minerals?
Give a very brief answer. 0.24. In the year 1979, what is the difference between the Cost (as % of GNI) in Coal and Cost (as % of GNI) in Energy?
Offer a very short reply. 0.18. In the year 1979, what is the difference between the Cost (as % of GNI) in Coal and Cost (as % of GNI) in Water?
Provide a short and direct response. 0.18. In the year 1979, what is the difference between the Cost (as % of GNI) of Minerals and Cost (as % of GNI) of Energy?
Provide a short and direct response. -0.06. In the year 1979, what is the difference between the Cost (as % of GNI) of Minerals and Cost (as % of GNI) of Water?
Keep it short and to the point. -0.06. In the year 1979, what is the difference between the Cost (as % of GNI) of Energy and Cost (as % of GNI) of Water?
Make the answer very short. -0. In the year 1980, what is the difference between the Cost (as % of GNI) of Coal and Cost (as % of GNI) of Minerals?
Ensure brevity in your answer.  0.25. In the year 1980, what is the difference between the Cost (as % of GNI) of Coal and Cost (as % of GNI) of Energy?
Ensure brevity in your answer.  0.2. In the year 1980, what is the difference between the Cost (as % of GNI) of Coal and Cost (as % of GNI) of Water?
Provide a succinct answer. 0.19. In the year 1980, what is the difference between the Cost (as % of GNI) of Minerals and Cost (as % of GNI) of Energy?
Your answer should be very brief. -0.05. In the year 1980, what is the difference between the Cost (as % of GNI) in Minerals and Cost (as % of GNI) in Water?
Your answer should be compact. -0.06. In the year 1980, what is the difference between the Cost (as % of GNI) of Energy and Cost (as % of GNI) of Water?
Keep it short and to the point. -0.01. In the year 1989, what is the difference between the Cost (as % of GNI) of Coal and Cost (as % of GNI) of Minerals?
Offer a very short reply. 0.19. In the year 1989, what is the difference between the Cost (as % of GNI) in Coal and Cost (as % of GNI) in Energy?
Ensure brevity in your answer.  -0.24. In the year 1989, what is the difference between the Cost (as % of GNI) of Coal and Cost (as % of GNI) of Water?
Provide a succinct answer. -0.26. In the year 1989, what is the difference between the Cost (as % of GNI) in Minerals and Cost (as % of GNI) in Energy?
Your response must be concise. -0.43. In the year 1989, what is the difference between the Cost (as % of GNI) in Minerals and Cost (as % of GNI) in Water?
Give a very brief answer. -0.46. In the year 1989, what is the difference between the Cost (as % of GNI) in Energy and Cost (as % of GNI) in Water?
Offer a very short reply. -0.03. In the year 1990, what is the difference between the Cost (as % of GNI) of Coal and Cost (as % of GNI) of Minerals?
Provide a succinct answer. 0.18. In the year 1990, what is the difference between the Cost (as % of GNI) in Coal and Cost (as % of GNI) in Energy?
Ensure brevity in your answer.  -0.38. In the year 1990, what is the difference between the Cost (as % of GNI) of Coal and Cost (as % of GNI) of Water?
Ensure brevity in your answer.  -0.4. In the year 1990, what is the difference between the Cost (as % of GNI) of Minerals and Cost (as % of GNI) of Energy?
Your response must be concise. -0.56. In the year 1990, what is the difference between the Cost (as % of GNI) of Minerals and Cost (as % of GNI) of Water?
Your answer should be compact. -0.58. In the year 1990, what is the difference between the Cost (as % of GNI) of Energy and Cost (as % of GNI) of Water?
Your answer should be very brief. -0.02. In the year 2005, what is the difference between the Cost (as % of GNI) of Coal and Cost (as % of GNI) of Minerals?
Keep it short and to the point. 0.14. In the year 2005, what is the difference between the Cost (as % of GNI) in Coal and Cost (as % of GNI) in Energy?
Provide a succinct answer. -2.64. In the year 2005, what is the difference between the Cost (as % of GNI) in Coal and Cost (as % of GNI) in Water?
Ensure brevity in your answer.  -2.65. In the year 2005, what is the difference between the Cost (as % of GNI) in Minerals and Cost (as % of GNI) in Energy?
Offer a terse response. -2.78. In the year 2005, what is the difference between the Cost (as % of GNI) of Minerals and Cost (as % of GNI) of Water?
Your response must be concise. -2.79. In the year 2005, what is the difference between the Cost (as % of GNI) of Energy and Cost (as % of GNI) of Water?
Keep it short and to the point. -0.01. In the year 2006, what is the difference between the Cost (as % of GNI) in Coal and Cost (as % of GNI) in Minerals?
Ensure brevity in your answer.  0.16. In the year 2006, what is the difference between the Cost (as % of GNI) of Coal and Cost (as % of GNI) of Energy?
Ensure brevity in your answer.  -2.58. In the year 2006, what is the difference between the Cost (as % of GNI) of Coal and Cost (as % of GNI) of Water?
Your answer should be compact. -2.58. In the year 2006, what is the difference between the Cost (as % of GNI) in Minerals and Cost (as % of GNI) in Energy?
Offer a terse response. -2.74. In the year 2006, what is the difference between the Cost (as % of GNI) in Minerals and Cost (as % of GNI) in Water?
Your answer should be compact. -2.74. In the year 2006, what is the difference between the Cost (as % of GNI) in Energy and Cost (as % of GNI) in Water?
Make the answer very short. -0.01. What is the ratio of the Cost (as % of GNI) in Coal in 1977 to that in 1978?
Offer a very short reply. 1.14. What is the ratio of the Cost (as % of GNI) in Minerals in 1977 to that in 1978?
Offer a very short reply. 1.29. What is the ratio of the Cost (as % of GNI) of Energy in 1977 to that in 1978?
Your answer should be compact. 1.48. What is the ratio of the Cost (as % of GNI) of Water in 1977 to that in 1978?
Give a very brief answer. 1.48. What is the ratio of the Cost (as % of GNI) of Coal in 1977 to that in 1979?
Keep it short and to the point. 1.16. What is the ratio of the Cost (as % of GNI) of Minerals in 1977 to that in 1979?
Ensure brevity in your answer.  0.65. What is the ratio of the Cost (as % of GNI) of Energy in 1977 to that in 1979?
Your answer should be very brief. 0.7. What is the ratio of the Cost (as % of GNI) in Water in 1977 to that in 1979?
Keep it short and to the point. 0.69. What is the ratio of the Cost (as % of GNI) in Coal in 1977 to that in 1980?
Make the answer very short. 1.1. What is the ratio of the Cost (as % of GNI) in Minerals in 1977 to that in 1980?
Give a very brief answer. 0.06. What is the ratio of the Cost (as % of GNI) of Energy in 1977 to that in 1980?
Make the answer very short. 0.8. What is the ratio of the Cost (as % of GNI) in Water in 1977 to that in 1980?
Offer a very short reply. 0.62. What is the ratio of the Cost (as % of GNI) of Coal in 1977 to that in 1989?
Offer a very short reply. 1.31. What is the ratio of the Cost (as % of GNI) in Minerals in 1977 to that in 1989?
Offer a terse response. 0.01. What is the ratio of the Cost (as % of GNI) in Energy in 1977 to that in 1989?
Your answer should be very brief. 0.09. What is the ratio of the Cost (as % of GNI) of Water in 1977 to that in 1989?
Provide a succinct answer. 0.08. What is the ratio of the Cost (as % of GNI) in Coal in 1977 to that in 1990?
Ensure brevity in your answer.  1.49. What is the ratio of the Cost (as % of GNI) of Minerals in 1977 to that in 1990?
Provide a succinct answer. 0.03. What is the ratio of the Cost (as % of GNI) of Energy in 1977 to that in 1990?
Your response must be concise. 0.07. What is the ratio of the Cost (as % of GNI) of Water in 1977 to that in 1990?
Ensure brevity in your answer.  0.07. What is the ratio of the Cost (as % of GNI) in Coal in 1977 to that in 2005?
Your answer should be compact. 1.92. What is the ratio of the Cost (as % of GNI) of Minerals in 1977 to that in 2005?
Provide a succinct answer. 0.09. What is the ratio of the Cost (as % of GNI) in Energy in 1977 to that in 2005?
Make the answer very short. 0.01. What is the ratio of the Cost (as % of GNI) in Water in 1977 to that in 2005?
Ensure brevity in your answer.  0.01. What is the ratio of the Cost (as % of GNI) in Coal in 1977 to that in 2006?
Offer a very short reply. 1.7. What is the ratio of the Cost (as % of GNI) in Minerals in 1977 to that in 2006?
Offer a very short reply. 0.1. What is the ratio of the Cost (as % of GNI) in Energy in 1977 to that in 2006?
Your answer should be compact. 0.01. What is the ratio of the Cost (as % of GNI) of Water in 1977 to that in 2006?
Make the answer very short. 0.01. What is the ratio of the Cost (as % of GNI) of Coal in 1978 to that in 1979?
Offer a terse response. 1.02. What is the ratio of the Cost (as % of GNI) of Minerals in 1978 to that in 1979?
Make the answer very short. 0.5. What is the ratio of the Cost (as % of GNI) in Energy in 1978 to that in 1979?
Give a very brief answer. 0.47. What is the ratio of the Cost (as % of GNI) in Water in 1978 to that in 1979?
Offer a terse response. 0.46. What is the ratio of the Cost (as % of GNI) of Coal in 1978 to that in 1980?
Provide a short and direct response. 0.97. What is the ratio of the Cost (as % of GNI) of Minerals in 1978 to that in 1980?
Your answer should be very brief. 0.05. What is the ratio of the Cost (as % of GNI) in Energy in 1978 to that in 1980?
Your answer should be very brief. 0.54. What is the ratio of the Cost (as % of GNI) in Water in 1978 to that in 1980?
Your answer should be very brief. 0.42. What is the ratio of the Cost (as % of GNI) in Coal in 1978 to that in 1989?
Provide a short and direct response. 1.15. What is the ratio of the Cost (as % of GNI) of Minerals in 1978 to that in 1989?
Offer a terse response. 0.01. What is the ratio of the Cost (as % of GNI) in Energy in 1978 to that in 1989?
Your response must be concise. 0.06. What is the ratio of the Cost (as % of GNI) in Water in 1978 to that in 1989?
Give a very brief answer. 0.06. What is the ratio of the Cost (as % of GNI) of Coal in 1978 to that in 1990?
Offer a very short reply. 1.31. What is the ratio of the Cost (as % of GNI) in Minerals in 1978 to that in 1990?
Give a very brief answer. 0.03. What is the ratio of the Cost (as % of GNI) in Energy in 1978 to that in 1990?
Give a very brief answer. 0.05. What is the ratio of the Cost (as % of GNI) in Water in 1978 to that in 1990?
Offer a terse response. 0.04. What is the ratio of the Cost (as % of GNI) of Coal in 1978 to that in 2005?
Ensure brevity in your answer.  1.69. What is the ratio of the Cost (as % of GNI) of Minerals in 1978 to that in 2005?
Ensure brevity in your answer.  0.07. What is the ratio of the Cost (as % of GNI) of Energy in 1978 to that in 2005?
Offer a terse response. 0.01. What is the ratio of the Cost (as % of GNI) of Water in 1978 to that in 2005?
Ensure brevity in your answer.  0.01. What is the ratio of the Cost (as % of GNI) in Coal in 1978 to that in 2006?
Ensure brevity in your answer.  1.49. What is the ratio of the Cost (as % of GNI) of Minerals in 1978 to that in 2006?
Offer a very short reply. 0.08. What is the ratio of the Cost (as % of GNI) in Energy in 1978 to that in 2006?
Keep it short and to the point. 0.01. What is the ratio of the Cost (as % of GNI) of Water in 1978 to that in 2006?
Give a very brief answer. 0.01. What is the ratio of the Cost (as % of GNI) of Coal in 1979 to that in 1980?
Provide a short and direct response. 0.95. What is the ratio of the Cost (as % of GNI) of Minerals in 1979 to that in 1980?
Keep it short and to the point. 0.09. What is the ratio of the Cost (as % of GNI) of Energy in 1979 to that in 1980?
Give a very brief answer. 1.15. What is the ratio of the Cost (as % of GNI) in Water in 1979 to that in 1980?
Your answer should be compact. 0.9. What is the ratio of the Cost (as % of GNI) in Coal in 1979 to that in 1989?
Make the answer very short. 1.13. What is the ratio of the Cost (as % of GNI) in Minerals in 1979 to that in 1989?
Offer a terse response. 0.02. What is the ratio of the Cost (as % of GNI) of Energy in 1979 to that in 1989?
Your answer should be very brief. 0.12. What is the ratio of the Cost (as % of GNI) in Water in 1979 to that in 1989?
Give a very brief answer. 0.12. What is the ratio of the Cost (as % of GNI) of Coal in 1979 to that in 1990?
Your answer should be compact. 1.28. What is the ratio of the Cost (as % of GNI) in Minerals in 1979 to that in 1990?
Make the answer very short. 0.05. What is the ratio of the Cost (as % of GNI) of Energy in 1979 to that in 1990?
Your response must be concise. 0.1. What is the ratio of the Cost (as % of GNI) in Water in 1979 to that in 1990?
Offer a terse response. 0.1. What is the ratio of the Cost (as % of GNI) in Coal in 1979 to that in 2005?
Keep it short and to the point. 1.65. What is the ratio of the Cost (as % of GNI) in Minerals in 1979 to that in 2005?
Make the answer very short. 0.14. What is the ratio of the Cost (as % of GNI) of Energy in 1979 to that in 2005?
Provide a succinct answer. 0.02. What is the ratio of the Cost (as % of GNI) of Water in 1979 to that in 2005?
Your answer should be compact. 0.02. What is the ratio of the Cost (as % of GNI) of Coal in 1979 to that in 2006?
Provide a succinct answer. 1.46. What is the ratio of the Cost (as % of GNI) in Minerals in 1979 to that in 2006?
Offer a terse response. 0.15. What is the ratio of the Cost (as % of GNI) in Energy in 1979 to that in 2006?
Make the answer very short. 0.02. What is the ratio of the Cost (as % of GNI) in Water in 1979 to that in 2006?
Offer a terse response. 0.02. What is the ratio of the Cost (as % of GNI) in Coal in 1980 to that in 1989?
Provide a short and direct response. 1.19. What is the ratio of the Cost (as % of GNI) of Minerals in 1980 to that in 1989?
Offer a terse response. 0.18. What is the ratio of the Cost (as % of GNI) of Energy in 1980 to that in 1989?
Provide a short and direct response. 0.11. What is the ratio of the Cost (as % of GNI) of Water in 1980 to that in 1989?
Offer a terse response. 0.13. What is the ratio of the Cost (as % of GNI) in Coal in 1980 to that in 1990?
Offer a terse response. 1.36. What is the ratio of the Cost (as % of GNI) of Minerals in 1980 to that in 1990?
Give a very brief answer. 0.57. What is the ratio of the Cost (as % of GNI) of Energy in 1980 to that in 1990?
Provide a short and direct response. 0.09. What is the ratio of the Cost (as % of GNI) in Water in 1980 to that in 1990?
Offer a terse response. 0.11. What is the ratio of the Cost (as % of GNI) in Coal in 1980 to that in 2005?
Your answer should be compact. 1.75. What is the ratio of the Cost (as % of GNI) of Minerals in 1980 to that in 2005?
Provide a short and direct response. 1.57. What is the ratio of the Cost (as % of GNI) of Energy in 1980 to that in 2005?
Provide a succinct answer. 0.02. What is the ratio of the Cost (as % of GNI) in Water in 1980 to that in 2005?
Your answer should be very brief. 0.02. What is the ratio of the Cost (as % of GNI) of Coal in 1980 to that in 2006?
Keep it short and to the point. 1.54. What is the ratio of the Cost (as % of GNI) of Minerals in 1980 to that in 2006?
Keep it short and to the point. 1.67. What is the ratio of the Cost (as % of GNI) in Energy in 1980 to that in 2006?
Offer a very short reply. 0.02. What is the ratio of the Cost (as % of GNI) of Water in 1980 to that in 2006?
Give a very brief answer. 0.02. What is the ratio of the Cost (as % of GNI) in Coal in 1989 to that in 1990?
Your answer should be very brief. 1.14. What is the ratio of the Cost (as % of GNI) in Minerals in 1989 to that in 1990?
Give a very brief answer. 3.16. What is the ratio of the Cost (as % of GNI) of Energy in 1989 to that in 1990?
Offer a terse response. 0.8. What is the ratio of the Cost (as % of GNI) of Water in 1989 to that in 1990?
Provide a short and direct response. 0.82. What is the ratio of the Cost (as % of GNI) of Coal in 1989 to that in 2005?
Ensure brevity in your answer.  1.47. What is the ratio of the Cost (as % of GNI) in Minerals in 1989 to that in 2005?
Keep it short and to the point. 8.69. What is the ratio of the Cost (as % of GNI) in Energy in 1989 to that in 2005?
Provide a succinct answer. 0.16. What is the ratio of the Cost (as % of GNI) in Water in 1989 to that in 2005?
Your answer should be compact. 0.17. What is the ratio of the Cost (as % of GNI) in Coal in 1989 to that in 2006?
Offer a very short reply. 1.3. What is the ratio of the Cost (as % of GNI) of Minerals in 1989 to that in 2006?
Give a very brief answer. 9.26. What is the ratio of the Cost (as % of GNI) of Energy in 1989 to that in 2006?
Offer a very short reply. 0.16. What is the ratio of the Cost (as % of GNI) of Water in 1989 to that in 2006?
Your response must be concise. 0.17. What is the ratio of the Cost (as % of GNI) of Coal in 1990 to that in 2005?
Ensure brevity in your answer.  1.29. What is the ratio of the Cost (as % of GNI) of Minerals in 1990 to that in 2005?
Your answer should be very brief. 2.75. What is the ratio of the Cost (as % of GNI) in Energy in 1990 to that in 2005?
Provide a succinct answer. 0.2. What is the ratio of the Cost (as % of GNI) in Water in 1990 to that in 2005?
Offer a very short reply. 0.21. What is the ratio of the Cost (as % of GNI) of Coal in 1990 to that in 2006?
Offer a terse response. 1.14. What is the ratio of the Cost (as % of GNI) of Minerals in 1990 to that in 2006?
Offer a terse response. 2.93. What is the ratio of the Cost (as % of GNI) of Energy in 1990 to that in 2006?
Offer a terse response. 0.2. What is the ratio of the Cost (as % of GNI) in Water in 1990 to that in 2006?
Give a very brief answer. 0.21. What is the ratio of the Cost (as % of GNI) of Coal in 2005 to that in 2006?
Give a very brief answer. 0.88. What is the ratio of the Cost (as % of GNI) in Minerals in 2005 to that in 2006?
Provide a short and direct response. 1.07. What is the ratio of the Cost (as % of GNI) in Energy in 2005 to that in 2006?
Offer a terse response. 1.02. What is the ratio of the Cost (as % of GNI) in Water in 2005 to that in 2006?
Provide a short and direct response. 1.02. What is the difference between the highest and the second highest Cost (as % of GNI) in Coal?
Offer a very short reply. 0.02. What is the difference between the highest and the second highest Cost (as % of GNI) in Minerals?
Your response must be concise. 0.01. What is the difference between the highest and the second highest Cost (as % of GNI) in Energy?
Ensure brevity in your answer.  0.04. What is the difference between the highest and the second highest Cost (as % of GNI) of Water?
Make the answer very short. 0.05. What is the difference between the highest and the lowest Cost (as % of GNI) of Coal?
Your response must be concise. 0.13. What is the difference between the highest and the lowest Cost (as % of GNI) in Minerals?
Make the answer very short. 0.02. What is the difference between the highest and the lowest Cost (as % of GNI) in Energy?
Your response must be concise. 2.75. What is the difference between the highest and the lowest Cost (as % of GNI) of Water?
Your answer should be compact. 2.77. 